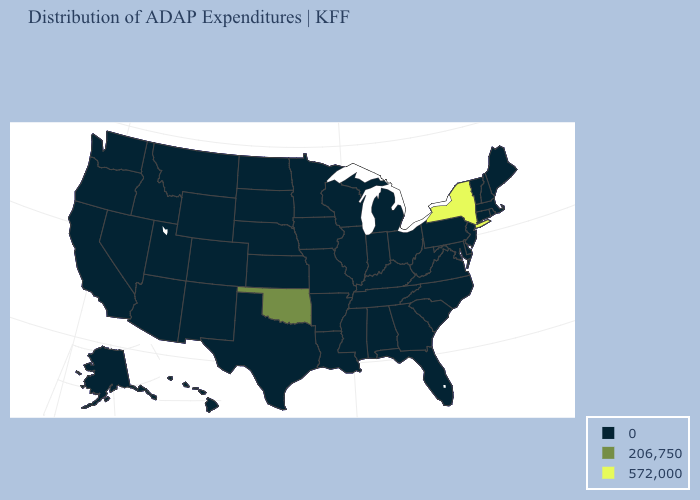What is the value of Massachusetts?
Answer briefly. 0. Does Oklahoma have the lowest value in the USA?
Give a very brief answer. No. Does the map have missing data?
Give a very brief answer. No. What is the highest value in the USA?
Write a very short answer. 572,000. Does the map have missing data?
Short answer required. No. What is the highest value in states that border Pennsylvania?
Give a very brief answer. 572,000. Which states have the highest value in the USA?
Write a very short answer. New York. Name the states that have a value in the range 206,750?
Quick response, please. Oklahoma. Does New York have the highest value in the Northeast?
Write a very short answer. Yes. Does the first symbol in the legend represent the smallest category?
Give a very brief answer. Yes. Name the states that have a value in the range 572,000?
Be succinct. New York. What is the lowest value in the USA?
Give a very brief answer. 0. Among the states that border Pennsylvania , which have the highest value?
Concise answer only. New York. What is the value of Wisconsin?
Write a very short answer. 0. Which states have the lowest value in the USA?
Keep it brief. Alabama, Alaska, Arizona, Arkansas, California, Colorado, Connecticut, Delaware, Florida, Georgia, Hawaii, Idaho, Illinois, Indiana, Iowa, Kansas, Kentucky, Louisiana, Maine, Maryland, Massachusetts, Michigan, Minnesota, Mississippi, Missouri, Montana, Nebraska, Nevada, New Hampshire, New Jersey, New Mexico, North Carolina, North Dakota, Ohio, Oregon, Pennsylvania, Rhode Island, South Carolina, South Dakota, Tennessee, Texas, Utah, Vermont, Virginia, Washington, West Virginia, Wisconsin, Wyoming. 